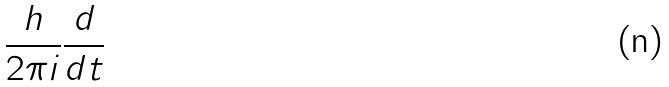<formula> <loc_0><loc_0><loc_500><loc_500>\frac { h } { 2 \pi i } \frac { d } { d t }</formula> 